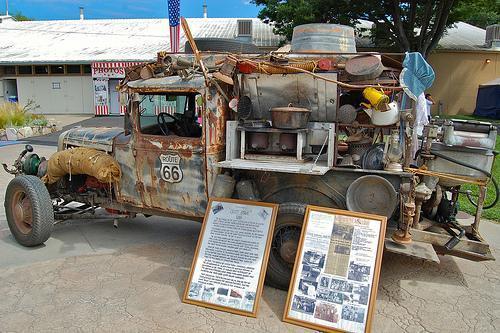How many vehicles?
Give a very brief answer. 1. 